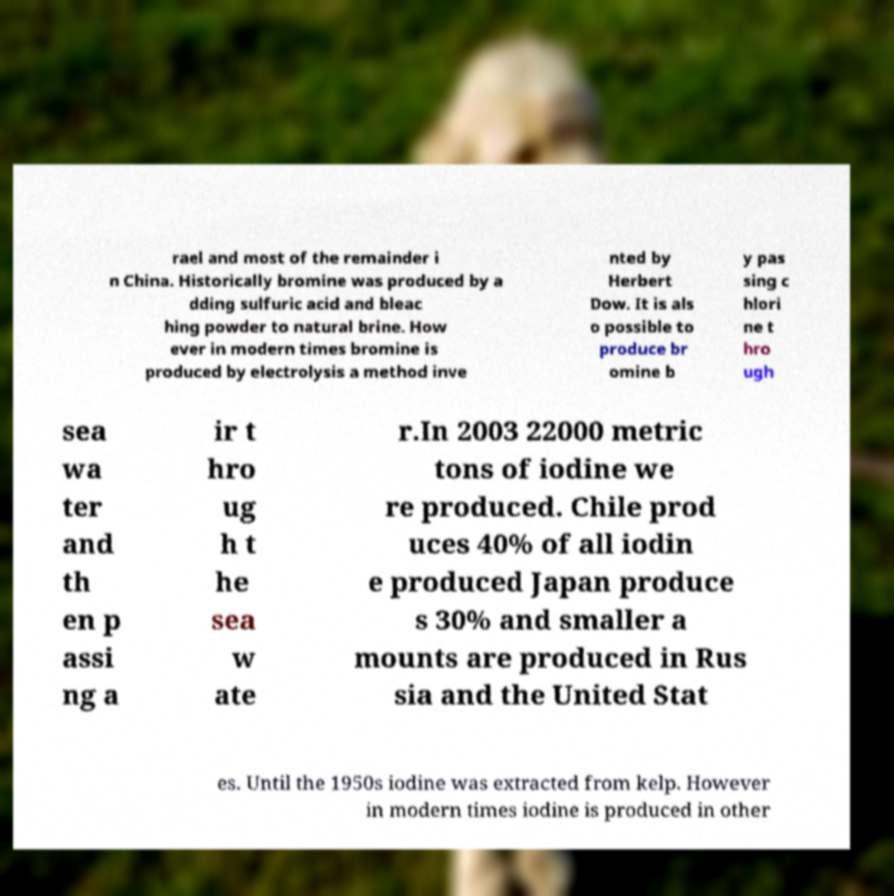Please read and relay the text visible in this image. What does it say? rael and most of the remainder i n China. Historically bromine was produced by a dding sulfuric acid and bleac hing powder to natural brine. How ever in modern times bromine is produced by electrolysis a method inve nted by Herbert Dow. It is als o possible to produce br omine b y pas sing c hlori ne t hro ugh sea wa ter and th en p assi ng a ir t hro ug h t he sea w ate r.In 2003 22000 metric tons of iodine we re produced. Chile prod uces 40% of all iodin e produced Japan produce s 30% and smaller a mounts are produced in Rus sia and the United Stat es. Until the 1950s iodine was extracted from kelp. However in modern times iodine is produced in other 